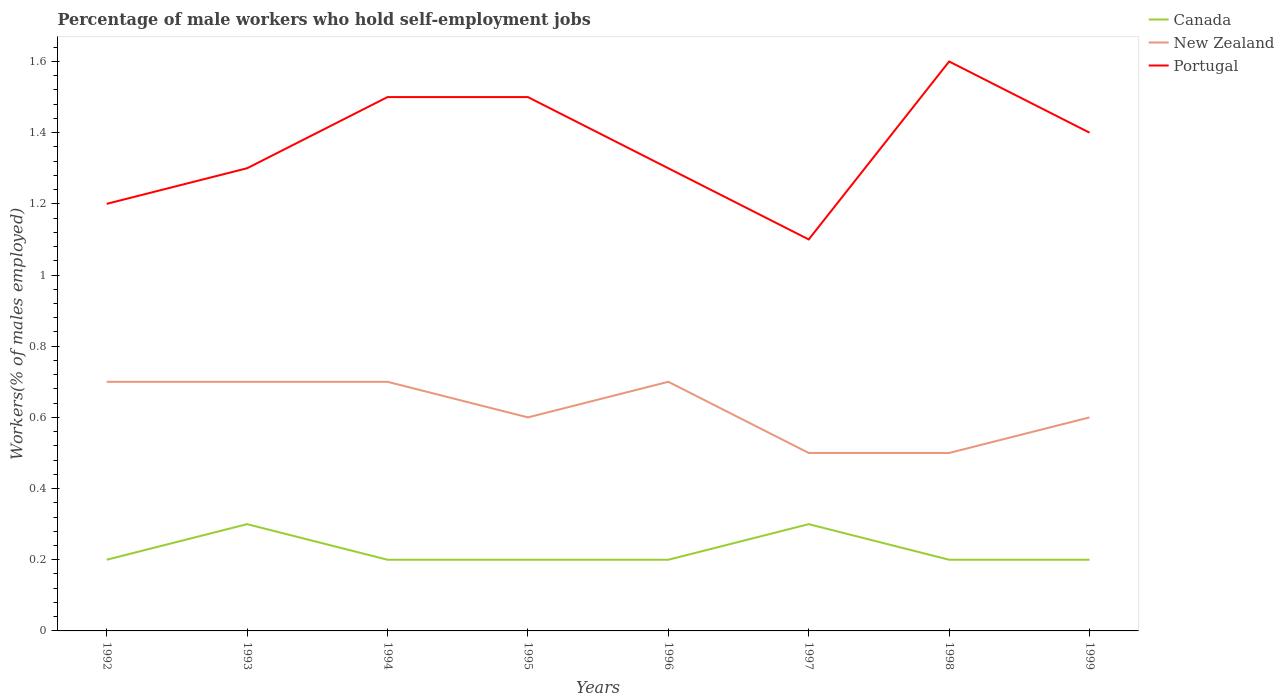Across all years, what is the maximum percentage of self-employed male workers in Portugal?
Provide a succinct answer. 1.1. In which year was the percentage of self-employed male workers in Canada maximum?
Provide a short and direct response. 1992. What is the total percentage of self-employed male workers in New Zealand in the graph?
Offer a very short reply. -0.1. What is the difference between the highest and the second highest percentage of self-employed male workers in Canada?
Your answer should be very brief. 0.1. Is the percentage of self-employed male workers in New Zealand strictly greater than the percentage of self-employed male workers in Portugal over the years?
Give a very brief answer. Yes. Does the graph contain any zero values?
Provide a short and direct response. No. How many legend labels are there?
Keep it short and to the point. 3. What is the title of the graph?
Give a very brief answer. Percentage of male workers who hold self-employment jobs. What is the label or title of the Y-axis?
Make the answer very short. Workers(% of males employed). What is the Workers(% of males employed) in Canada in 1992?
Offer a very short reply. 0.2. What is the Workers(% of males employed) of New Zealand in 1992?
Provide a short and direct response. 0.7. What is the Workers(% of males employed) in Portugal in 1992?
Your answer should be compact. 1.2. What is the Workers(% of males employed) of Canada in 1993?
Your answer should be compact. 0.3. What is the Workers(% of males employed) in New Zealand in 1993?
Offer a very short reply. 0.7. What is the Workers(% of males employed) in Portugal in 1993?
Ensure brevity in your answer.  1.3. What is the Workers(% of males employed) in Canada in 1994?
Your answer should be compact. 0.2. What is the Workers(% of males employed) of New Zealand in 1994?
Your answer should be compact. 0.7. What is the Workers(% of males employed) in Portugal in 1994?
Provide a short and direct response. 1.5. What is the Workers(% of males employed) of Canada in 1995?
Keep it short and to the point. 0.2. What is the Workers(% of males employed) of New Zealand in 1995?
Your answer should be compact. 0.6. What is the Workers(% of males employed) of Portugal in 1995?
Make the answer very short. 1.5. What is the Workers(% of males employed) of Canada in 1996?
Offer a very short reply. 0.2. What is the Workers(% of males employed) in New Zealand in 1996?
Give a very brief answer. 0.7. What is the Workers(% of males employed) in Portugal in 1996?
Your answer should be very brief. 1.3. What is the Workers(% of males employed) of Canada in 1997?
Your answer should be compact. 0.3. What is the Workers(% of males employed) of Portugal in 1997?
Provide a short and direct response. 1.1. What is the Workers(% of males employed) in Canada in 1998?
Give a very brief answer. 0.2. What is the Workers(% of males employed) of Portugal in 1998?
Your response must be concise. 1.6. What is the Workers(% of males employed) of Canada in 1999?
Your response must be concise. 0.2. What is the Workers(% of males employed) of New Zealand in 1999?
Keep it short and to the point. 0.6. What is the Workers(% of males employed) of Portugal in 1999?
Provide a short and direct response. 1.4. Across all years, what is the maximum Workers(% of males employed) in Canada?
Your answer should be very brief. 0.3. Across all years, what is the maximum Workers(% of males employed) in New Zealand?
Offer a very short reply. 0.7. Across all years, what is the maximum Workers(% of males employed) of Portugal?
Provide a succinct answer. 1.6. Across all years, what is the minimum Workers(% of males employed) in Canada?
Provide a short and direct response. 0.2. Across all years, what is the minimum Workers(% of males employed) of Portugal?
Ensure brevity in your answer.  1.1. What is the total Workers(% of males employed) of New Zealand in the graph?
Give a very brief answer. 5. What is the total Workers(% of males employed) in Portugal in the graph?
Your response must be concise. 10.9. What is the difference between the Workers(% of males employed) of New Zealand in 1992 and that in 1994?
Provide a succinct answer. 0. What is the difference between the Workers(% of males employed) in Portugal in 1992 and that in 1994?
Give a very brief answer. -0.3. What is the difference between the Workers(% of males employed) of Canada in 1992 and that in 1995?
Provide a short and direct response. 0. What is the difference between the Workers(% of males employed) in New Zealand in 1992 and that in 1995?
Provide a short and direct response. 0.1. What is the difference between the Workers(% of males employed) of Portugal in 1992 and that in 1995?
Offer a very short reply. -0.3. What is the difference between the Workers(% of males employed) in Canada in 1992 and that in 1997?
Offer a terse response. -0.1. What is the difference between the Workers(% of males employed) in New Zealand in 1992 and that in 1997?
Your answer should be very brief. 0.2. What is the difference between the Workers(% of males employed) in New Zealand in 1992 and that in 1998?
Provide a short and direct response. 0.2. What is the difference between the Workers(% of males employed) in Portugal in 1992 and that in 1999?
Provide a succinct answer. -0.2. What is the difference between the Workers(% of males employed) of Canada in 1993 and that in 1994?
Your response must be concise. 0.1. What is the difference between the Workers(% of males employed) of New Zealand in 1993 and that in 1994?
Provide a succinct answer. 0. What is the difference between the Workers(% of males employed) in Portugal in 1993 and that in 1994?
Give a very brief answer. -0.2. What is the difference between the Workers(% of males employed) of Portugal in 1993 and that in 1995?
Your answer should be compact. -0.2. What is the difference between the Workers(% of males employed) in New Zealand in 1993 and that in 1997?
Keep it short and to the point. 0.2. What is the difference between the Workers(% of males employed) in Portugal in 1993 and that in 1997?
Your answer should be compact. 0.2. What is the difference between the Workers(% of males employed) of New Zealand in 1994 and that in 1996?
Your answer should be compact. 0. What is the difference between the Workers(% of males employed) of Canada in 1994 and that in 1997?
Provide a short and direct response. -0.1. What is the difference between the Workers(% of males employed) in Portugal in 1994 and that in 1997?
Offer a very short reply. 0.4. What is the difference between the Workers(% of males employed) of Portugal in 1994 and that in 1998?
Offer a terse response. -0.1. What is the difference between the Workers(% of males employed) of New Zealand in 1994 and that in 1999?
Your answer should be compact. 0.1. What is the difference between the Workers(% of males employed) of Portugal in 1994 and that in 1999?
Your answer should be compact. 0.1. What is the difference between the Workers(% of males employed) in New Zealand in 1995 and that in 1996?
Ensure brevity in your answer.  -0.1. What is the difference between the Workers(% of males employed) of Portugal in 1995 and that in 1996?
Ensure brevity in your answer.  0.2. What is the difference between the Workers(% of males employed) in Canada in 1995 and that in 1997?
Your response must be concise. -0.1. What is the difference between the Workers(% of males employed) of New Zealand in 1995 and that in 1997?
Give a very brief answer. 0.1. What is the difference between the Workers(% of males employed) in Portugal in 1995 and that in 1997?
Provide a succinct answer. 0.4. What is the difference between the Workers(% of males employed) of New Zealand in 1995 and that in 1998?
Make the answer very short. 0.1. What is the difference between the Workers(% of males employed) of Portugal in 1995 and that in 1998?
Make the answer very short. -0.1. What is the difference between the Workers(% of males employed) in New Zealand in 1995 and that in 1999?
Offer a very short reply. 0. What is the difference between the Workers(% of males employed) of Portugal in 1995 and that in 1999?
Offer a very short reply. 0.1. What is the difference between the Workers(% of males employed) in Canada in 1996 and that in 1998?
Keep it short and to the point. 0. What is the difference between the Workers(% of males employed) in Canada in 1996 and that in 1999?
Your answer should be compact. 0. What is the difference between the Workers(% of males employed) of New Zealand in 1996 and that in 1999?
Your response must be concise. 0.1. What is the difference between the Workers(% of males employed) in Canada in 1997 and that in 1998?
Provide a short and direct response. 0.1. What is the difference between the Workers(% of males employed) of New Zealand in 1997 and that in 1998?
Offer a terse response. 0. What is the difference between the Workers(% of males employed) of Portugal in 1997 and that in 1998?
Make the answer very short. -0.5. What is the difference between the Workers(% of males employed) in Canada in 1997 and that in 1999?
Your answer should be very brief. 0.1. What is the difference between the Workers(% of males employed) of New Zealand in 1997 and that in 1999?
Give a very brief answer. -0.1. What is the difference between the Workers(% of males employed) of Canada in 1998 and that in 1999?
Make the answer very short. 0. What is the difference between the Workers(% of males employed) of Portugal in 1998 and that in 1999?
Your answer should be very brief. 0.2. What is the difference between the Workers(% of males employed) in Canada in 1992 and the Workers(% of males employed) in New Zealand in 1994?
Offer a terse response. -0.5. What is the difference between the Workers(% of males employed) of New Zealand in 1992 and the Workers(% of males employed) of Portugal in 1994?
Your answer should be compact. -0.8. What is the difference between the Workers(% of males employed) of Canada in 1992 and the Workers(% of males employed) of New Zealand in 1996?
Your answer should be very brief. -0.5. What is the difference between the Workers(% of males employed) of Canada in 1992 and the Workers(% of males employed) of Portugal in 1996?
Offer a very short reply. -1.1. What is the difference between the Workers(% of males employed) in New Zealand in 1992 and the Workers(% of males employed) in Portugal in 1997?
Provide a short and direct response. -0.4. What is the difference between the Workers(% of males employed) of Canada in 1992 and the Workers(% of males employed) of New Zealand in 1998?
Provide a short and direct response. -0.3. What is the difference between the Workers(% of males employed) of New Zealand in 1992 and the Workers(% of males employed) of Portugal in 1998?
Your answer should be very brief. -0.9. What is the difference between the Workers(% of males employed) in New Zealand in 1992 and the Workers(% of males employed) in Portugal in 1999?
Keep it short and to the point. -0.7. What is the difference between the Workers(% of males employed) of New Zealand in 1993 and the Workers(% of males employed) of Portugal in 1994?
Provide a succinct answer. -0.8. What is the difference between the Workers(% of males employed) in Canada in 1993 and the Workers(% of males employed) in Portugal in 1995?
Your response must be concise. -1.2. What is the difference between the Workers(% of males employed) of Canada in 1993 and the Workers(% of males employed) of Portugal in 1998?
Your answer should be compact. -1.3. What is the difference between the Workers(% of males employed) of Canada in 1993 and the Workers(% of males employed) of Portugal in 1999?
Your answer should be compact. -1.1. What is the difference between the Workers(% of males employed) in New Zealand in 1994 and the Workers(% of males employed) in Portugal in 1995?
Provide a succinct answer. -0.8. What is the difference between the Workers(% of males employed) of Canada in 1994 and the Workers(% of males employed) of New Zealand in 1996?
Make the answer very short. -0.5. What is the difference between the Workers(% of males employed) in Canada in 1994 and the Workers(% of males employed) in Portugal in 1996?
Keep it short and to the point. -1.1. What is the difference between the Workers(% of males employed) in Canada in 1994 and the Workers(% of males employed) in Portugal in 1997?
Make the answer very short. -0.9. What is the difference between the Workers(% of males employed) in New Zealand in 1994 and the Workers(% of males employed) in Portugal in 1997?
Provide a succinct answer. -0.4. What is the difference between the Workers(% of males employed) in Canada in 1994 and the Workers(% of males employed) in New Zealand in 1998?
Provide a succinct answer. -0.3. What is the difference between the Workers(% of males employed) of New Zealand in 1994 and the Workers(% of males employed) of Portugal in 1998?
Offer a terse response. -0.9. What is the difference between the Workers(% of males employed) of Canada in 1994 and the Workers(% of males employed) of New Zealand in 1999?
Provide a short and direct response. -0.4. What is the difference between the Workers(% of males employed) of Canada in 1994 and the Workers(% of males employed) of Portugal in 1999?
Offer a very short reply. -1.2. What is the difference between the Workers(% of males employed) in Canada in 1995 and the Workers(% of males employed) in New Zealand in 1996?
Offer a terse response. -0.5. What is the difference between the Workers(% of males employed) of Canada in 1995 and the Workers(% of males employed) of Portugal in 1997?
Provide a succinct answer. -0.9. What is the difference between the Workers(% of males employed) in Canada in 1995 and the Workers(% of males employed) in Portugal in 1998?
Provide a short and direct response. -1.4. What is the difference between the Workers(% of males employed) in New Zealand in 1995 and the Workers(% of males employed) in Portugal in 1999?
Offer a very short reply. -0.8. What is the difference between the Workers(% of males employed) in Canada in 1996 and the Workers(% of males employed) in New Zealand in 1997?
Offer a very short reply. -0.3. What is the difference between the Workers(% of males employed) in Canada in 1996 and the Workers(% of males employed) in New Zealand in 1998?
Your answer should be very brief. -0.3. What is the difference between the Workers(% of males employed) in Canada in 1996 and the Workers(% of males employed) in Portugal in 1998?
Offer a terse response. -1.4. What is the difference between the Workers(% of males employed) of New Zealand in 1996 and the Workers(% of males employed) of Portugal in 1998?
Make the answer very short. -0.9. What is the difference between the Workers(% of males employed) in Canada in 1996 and the Workers(% of males employed) in New Zealand in 1999?
Make the answer very short. -0.4. What is the difference between the Workers(% of males employed) of Canada in 1996 and the Workers(% of males employed) of Portugal in 1999?
Offer a terse response. -1.2. What is the difference between the Workers(% of males employed) of Canada in 1997 and the Workers(% of males employed) of Portugal in 1998?
Make the answer very short. -1.3. What is the difference between the Workers(% of males employed) of New Zealand in 1997 and the Workers(% of males employed) of Portugal in 1998?
Your answer should be compact. -1.1. What is the difference between the Workers(% of males employed) in Canada in 1997 and the Workers(% of males employed) in Portugal in 1999?
Make the answer very short. -1.1. What is the difference between the Workers(% of males employed) of New Zealand in 1997 and the Workers(% of males employed) of Portugal in 1999?
Make the answer very short. -0.9. What is the difference between the Workers(% of males employed) in Canada in 1998 and the Workers(% of males employed) in Portugal in 1999?
Offer a terse response. -1.2. What is the average Workers(% of males employed) in Canada per year?
Your answer should be compact. 0.23. What is the average Workers(% of males employed) in Portugal per year?
Your response must be concise. 1.36. In the year 1992, what is the difference between the Workers(% of males employed) of Canada and Workers(% of males employed) of New Zealand?
Your answer should be very brief. -0.5. In the year 1994, what is the difference between the Workers(% of males employed) in Canada and Workers(% of males employed) in New Zealand?
Keep it short and to the point. -0.5. In the year 1994, what is the difference between the Workers(% of males employed) in Canada and Workers(% of males employed) in Portugal?
Keep it short and to the point. -1.3. In the year 1995, what is the difference between the Workers(% of males employed) in Canada and Workers(% of males employed) in New Zealand?
Offer a terse response. -0.4. In the year 1995, what is the difference between the Workers(% of males employed) of Canada and Workers(% of males employed) of Portugal?
Your response must be concise. -1.3. In the year 1995, what is the difference between the Workers(% of males employed) in New Zealand and Workers(% of males employed) in Portugal?
Make the answer very short. -0.9. In the year 1996, what is the difference between the Workers(% of males employed) of Canada and Workers(% of males employed) of Portugal?
Your response must be concise. -1.1. In the year 1997, what is the difference between the Workers(% of males employed) of New Zealand and Workers(% of males employed) of Portugal?
Offer a terse response. -0.6. In the year 1998, what is the difference between the Workers(% of males employed) in Canada and Workers(% of males employed) in New Zealand?
Offer a very short reply. -0.3. In the year 1998, what is the difference between the Workers(% of males employed) of Canada and Workers(% of males employed) of Portugal?
Make the answer very short. -1.4. In the year 1999, what is the difference between the Workers(% of males employed) of Canada and Workers(% of males employed) of New Zealand?
Your answer should be compact. -0.4. In the year 1999, what is the difference between the Workers(% of males employed) of Canada and Workers(% of males employed) of Portugal?
Ensure brevity in your answer.  -1.2. In the year 1999, what is the difference between the Workers(% of males employed) of New Zealand and Workers(% of males employed) of Portugal?
Offer a terse response. -0.8. What is the ratio of the Workers(% of males employed) in New Zealand in 1992 to that in 1994?
Keep it short and to the point. 1. What is the ratio of the Workers(% of males employed) of Portugal in 1992 to that in 1995?
Ensure brevity in your answer.  0.8. What is the ratio of the Workers(% of males employed) of Portugal in 1992 to that in 1997?
Your answer should be compact. 1.09. What is the ratio of the Workers(% of males employed) in Portugal in 1992 to that in 1998?
Ensure brevity in your answer.  0.75. What is the ratio of the Workers(% of males employed) in New Zealand in 1992 to that in 1999?
Your response must be concise. 1.17. What is the ratio of the Workers(% of males employed) of Portugal in 1993 to that in 1994?
Keep it short and to the point. 0.87. What is the ratio of the Workers(% of males employed) of Portugal in 1993 to that in 1995?
Your response must be concise. 0.87. What is the ratio of the Workers(% of males employed) in Canada in 1993 to that in 1997?
Provide a succinct answer. 1. What is the ratio of the Workers(% of males employed) in Portugal in 1993 to that in 1997?
Make the answer very short. 1.18. What is the ratio of the Workers(% of males employed) in New Zealand in 1993 to that in 1998?
Provide a succinct answer. 1.4. What is the ratio of the Workers(% of males employed) of Portugal in 1993 to that in 1998?
Your answer should be compact. 0.81. What is the ratio of the Workers(% of males employed) in Canada in 1993 to that in 1999?
Keep it short and to the point. 1.5. What is the ratio of the Workers(% of males employed) of New Zealand in 1993 to that in 1999?
Provide a succinct answer. 1.17. What is the ratio of the Workers(% of males employed) in Portugal in 1993 to that in 1999?
Ensure brevity in your answer.  0.93. What is the ratio of the Workers(% of males employed) in Canada in 1994 to that in 1996?
Provide a short and direct response. 1. What is the ratio of the Workers(% of males employed) in New Zealand in 1994 to that in 1996?
Your answer should be compact. 1. What is the ratio of the Workers(% of males employed) of Portugal in 1994 to that in 1996?
Keep it short and to the point. 1.15. What is the ratio of the Workers(% of males employed) in Portugal in 1994 to that in 1997?
Your answer should be compact. 1.36. What is the ratio of the Workers(% of males employed) of New Zealand in 1994 to that in 1998?
Keep it short and to the point. 1.4. What is the ratio of the Workers(% of males employed) in Canada in 1994 to that in 1999?
Give a very brief answer. 1. What is the ratio of the Workers(% of males employed) of Portugal in 1994 to that in 1999?
Ensure brevity in your answer.  1.07. What is the ratio of the Workers(% of males employed) in Portugal in 1995 to that in 1996?
Ensure brevity in your answer.  1.15. What is the ratio of the Workers(% of males employed) in Canada in 1995 to that in 1997?
Make the answer very short. 0.67. What is the ratio of the Workers(% of males employed) in New Zealand in 1995 to that in 1997?
Your response must be concise. 1.2. What is the ratio of the Workers(% of males employed) of Portugal in 1995 to that in 1997?
Offer a very short reply. 1.36. What is the ratio of the Workers(% of males employed) in New Zealand in 1995 to that in 1998?
Make the answer very short. 1.2. What is the ratio of the Workers(% of males employed) in Canada in 1995 to that in 1999?
Offer a terse response. 1. What is the ratio of the Workers(% of males employed) in New Zealand in 1995 to that in 1999?
Provide a succinct answer. 1. What is the ratio of the Workers(% of males employed) in Portugal in 1995 to that in 1999?
Provide a succinct answer. 1.07. What is the ratio of the Workers(% of males employed) in Canada in 1996 to that in 1997?
Make the answer very short. 0.67. What is the ratio of the Workers(% of males employed) in Portugal in 1996 to that in 1997?
Offer a terse response. 1.18. What is the ratio of the Workers(% of males employed) in Canada in 1996 to that in 1998?
Make the answer very short. 1. What is the ratio of the Workers(% of males employed) in New Zealand in 1996 to that in 1998?
Offer a terse response. 1.4. What is the ratio of the Workers(% of males employed) in Portugal in 1996 to that in 1998?
Offer a very short reply. 0.81. What is the ratio of the Workers(% of males employed) in Canada in 1996 to that in 1999?
Provide a short and direct response. 1. What is the ratio of the Workers(% of males employed) of Canada in 1997 to that in 1998?
Offer a terse response. 1.5. What is the ratio of the Workers(% of males employed) of New Zealand in 1997 to that in 1998?
Offer a very short reply. 1. What is the ratio of the Workers(% of males employed) in Portugal in 1997 to that in 1998?
Provide a succinct answer. 0.69. What is the ratio of the Workers(% of males employed) of New Zealand in 1997 to that in 1999?
Make the answer very short. 0.83. What is the ratio of the Workers(% of males employed) of Portugal in 1997 to that in 1999?
Provide a succinct answer. 0.79. What is the ratio of the Workers(% of males employed) of Canada in 1998 to that in 1999?
Keep it short and to the point. 1. What is the ratio of the Workers(% of males employed) of New Zealand in 1998 to that in 1999?
Your response must be concise. 0.83. What is the difference between the highest and the lowest Workers(% of males employed) in Canada?
Keep it short and to the point. 0.1. What is the difference between the highest and the lowest Workers(% of males employed) of New Zealand?
Ensure brevity in your answer.  0.2. 